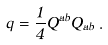Convert formula to latex. <formula><loc_0><loc_0><loc_500><loc_500>q = \frac { 1 } { 4 } Q ^ { a b } Q _ { a b } \, .</formula> 